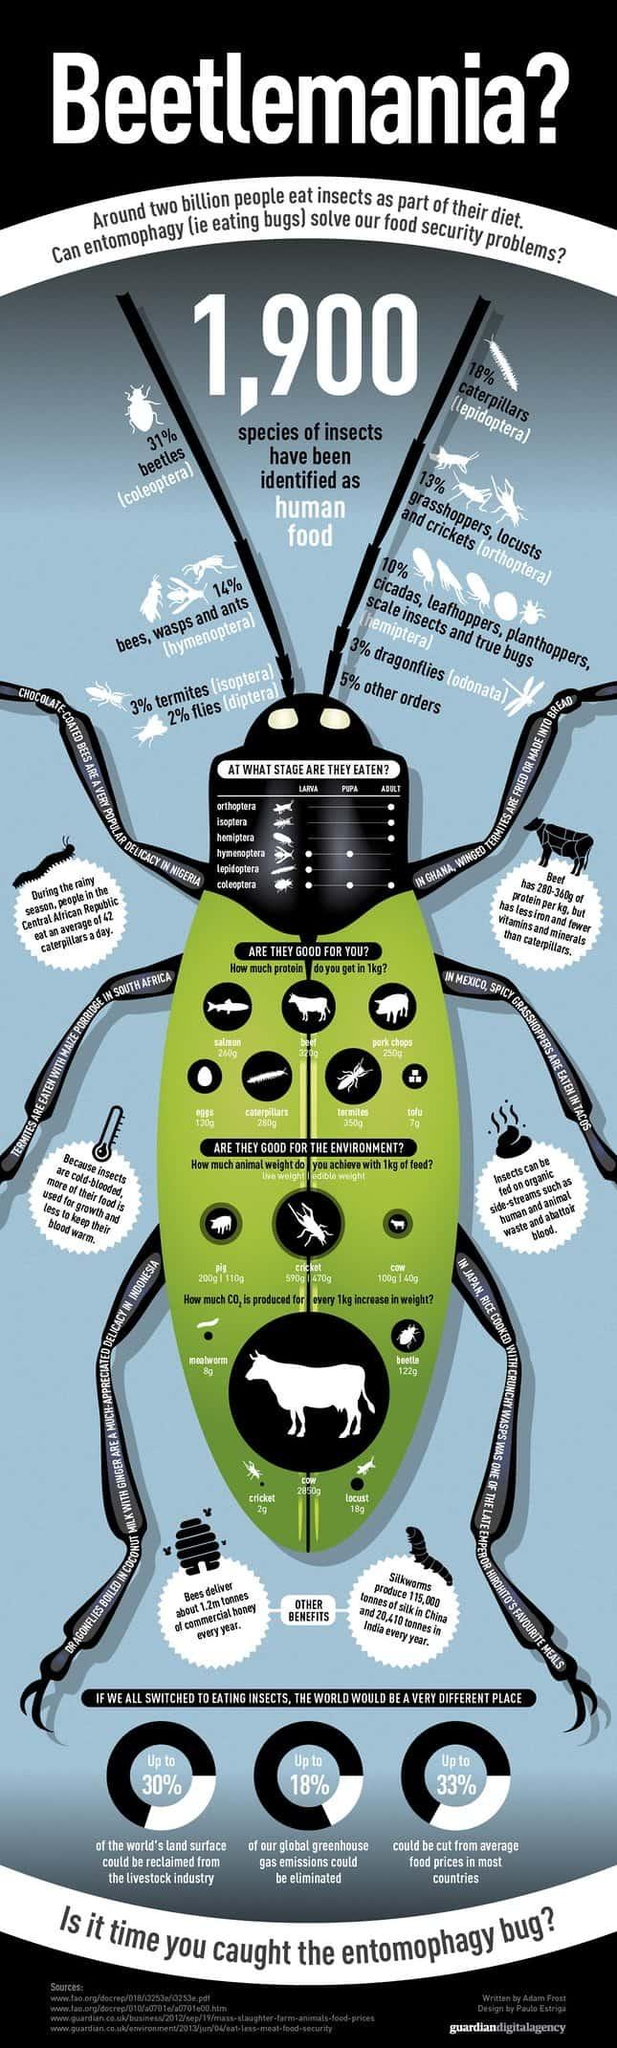Point out several critical features in this image. Insects are typically eaten after they reach adulthood, and this behavior occurs in a specified number of orders. Isoptera, the type of insect that is commonly referred to as "termites," are typically eaten during the adult stage. According to recent research, a significant percentage of insects, specifically those that are not beetles, make up 69% of all insect species. There is 130 grams of protein in 1 kilogram of eggs. According to recent studies, a significant proportion of insects, specifically caterpillars, make up 18% of the total insect population. 